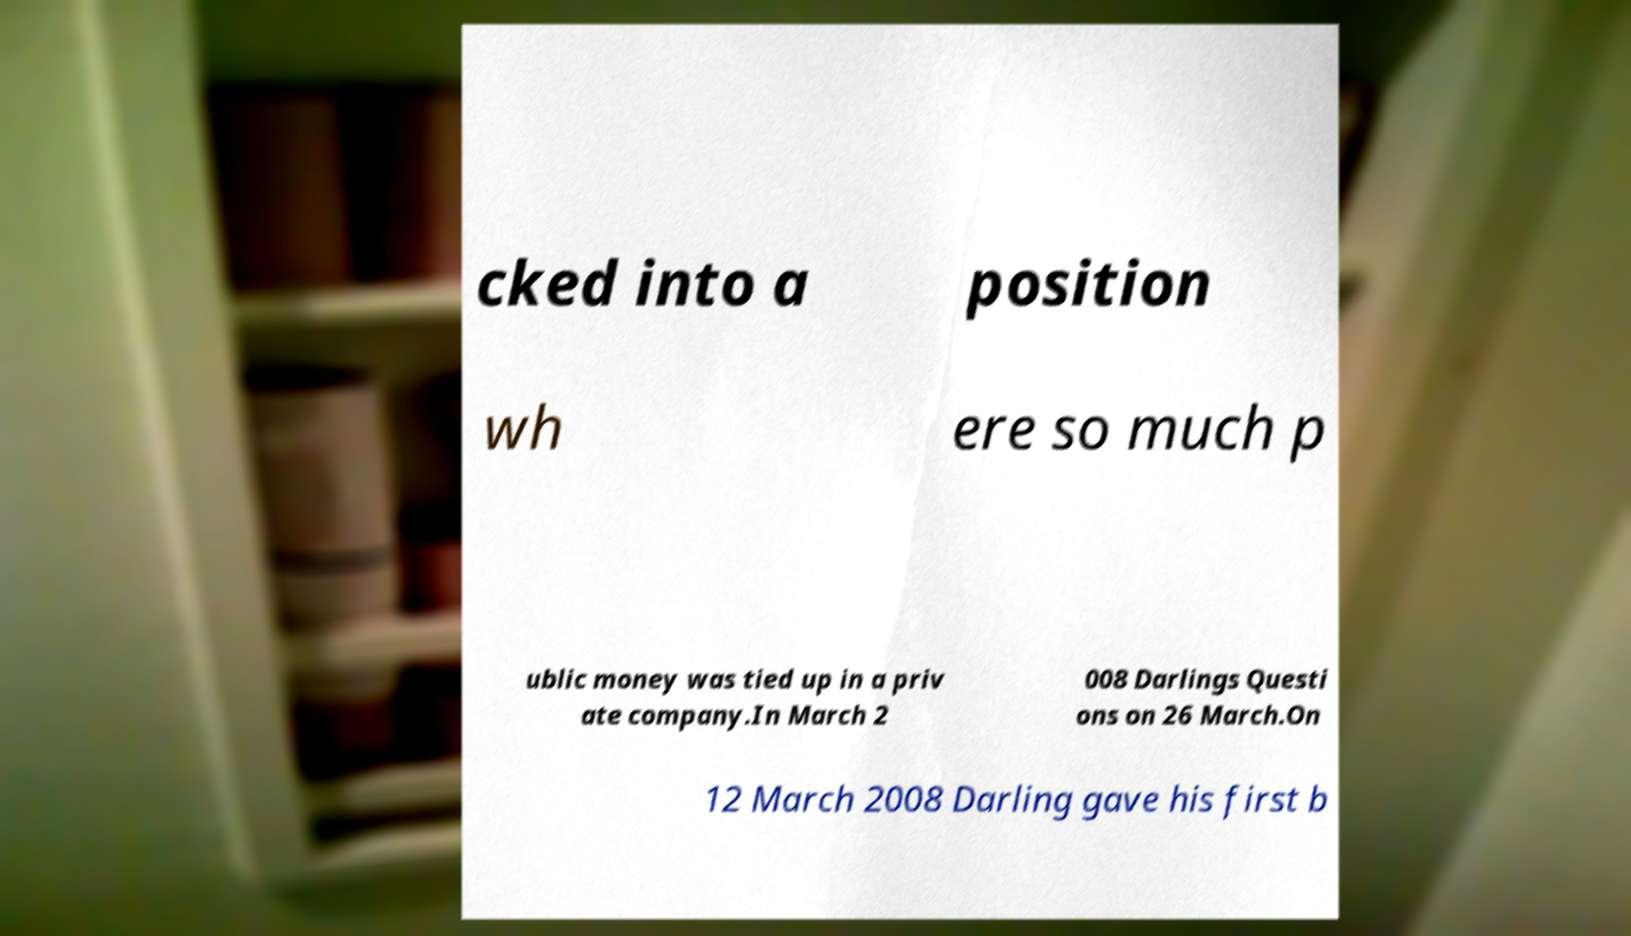Please read and relay the text visible in this image. What does it say? cked into a position wh ere so much p ublic money was tied up in a priv ate company.In March 2 008 Darlings Questi ons on 26 March.On 12 March 2008 Darling gave his first b 